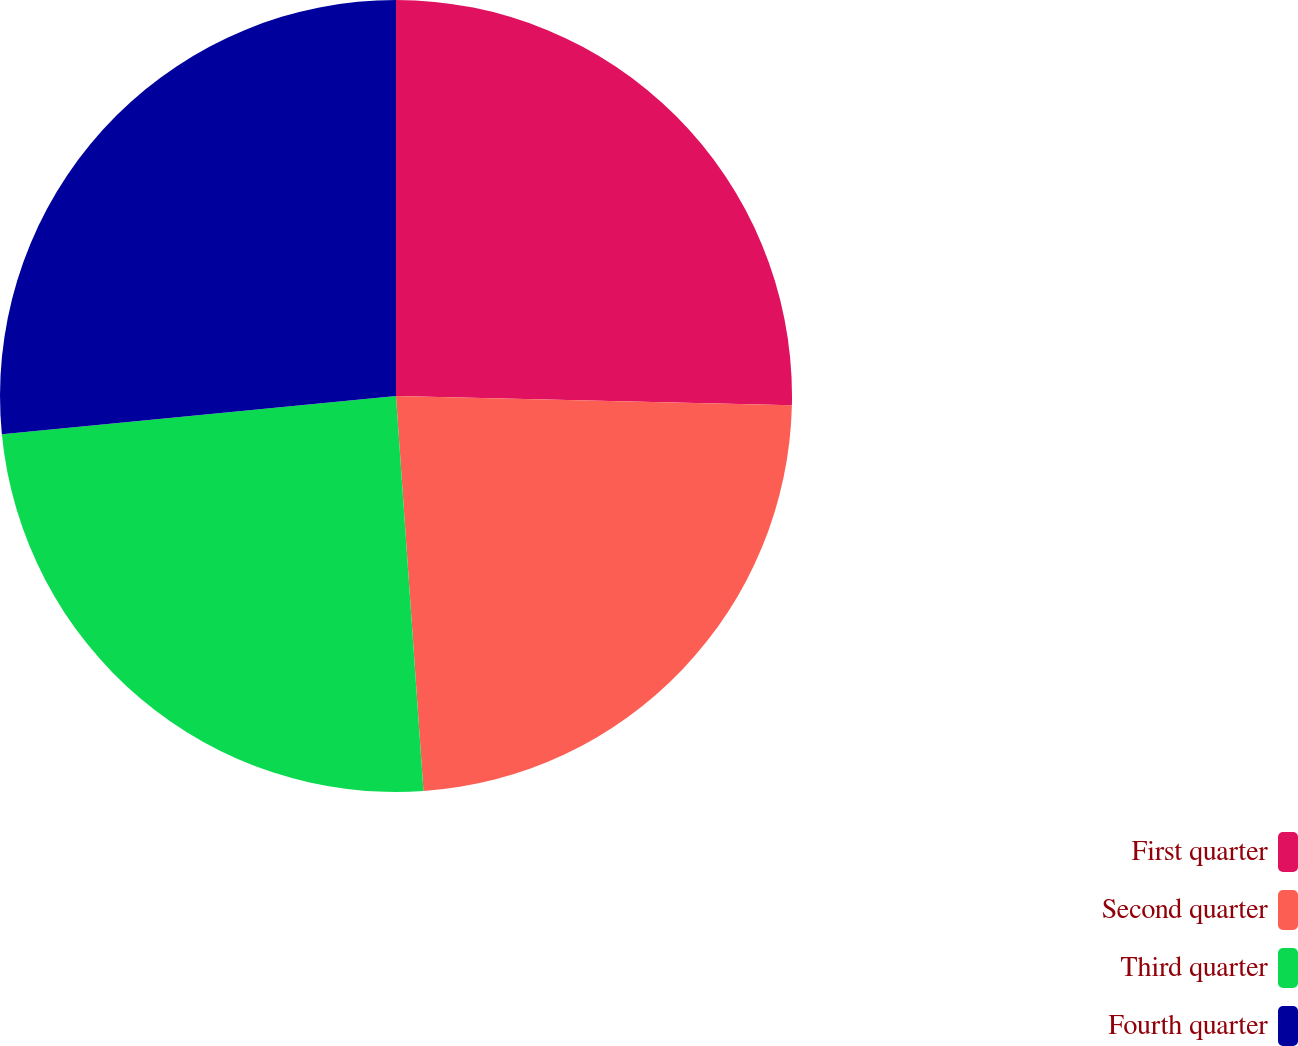Convert chart. <chart><loc_0><loc_0><loc_500><loc_500><pie_chart><fcel>First quarter<fcel>Second quarter<fcel>Third quarter<fcel>Fourth quarter<nl><fcel>25.37%<fcel>23.53%<fcel>24.57%<fcel>26.54%<nl></chart> 